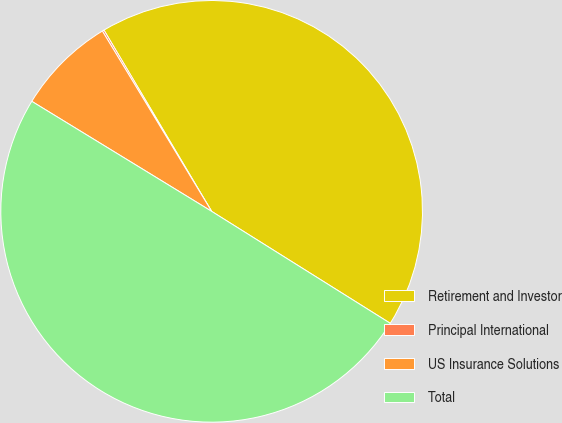<chart> <loc_0><loc_0><loc_500><loc_500><pie_chart><fcel>Retirement and Investor<fcel>Principal International<fcel>US Insurance Solutions<fcel>Total<nl><fcel>42.44%<fcel>0.14%<fcel>7.59%<fcel>49.82%<nl></chart> 